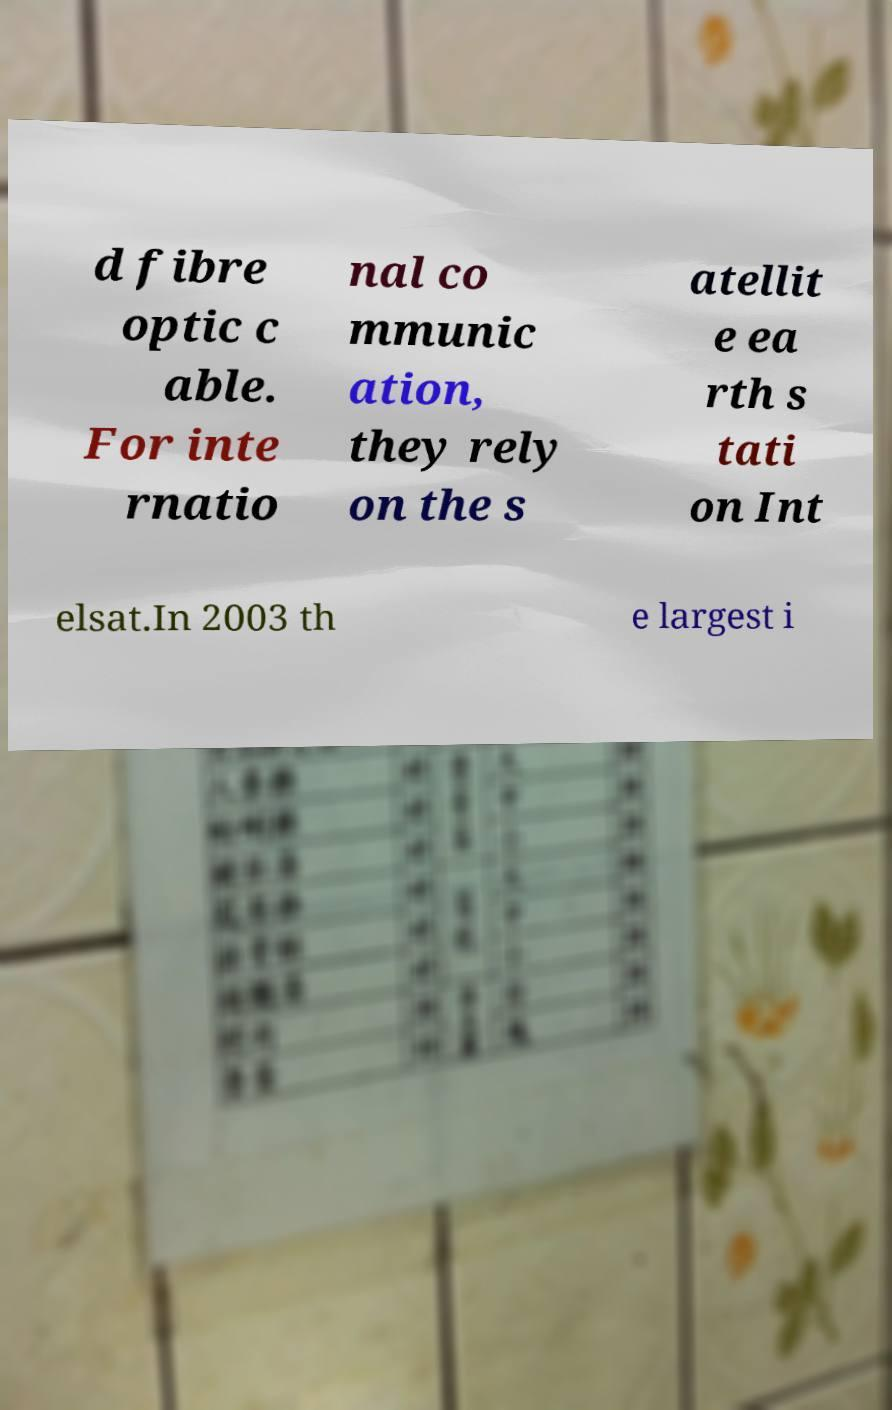What messages or text are displayed in this image? I need them in a readable, typed format. d fibre optic c able. For inte rnatio nal co mmunic ation, they rely on the s atellit e ea rth s tati on Int elsat.In 2003 th e largest i 